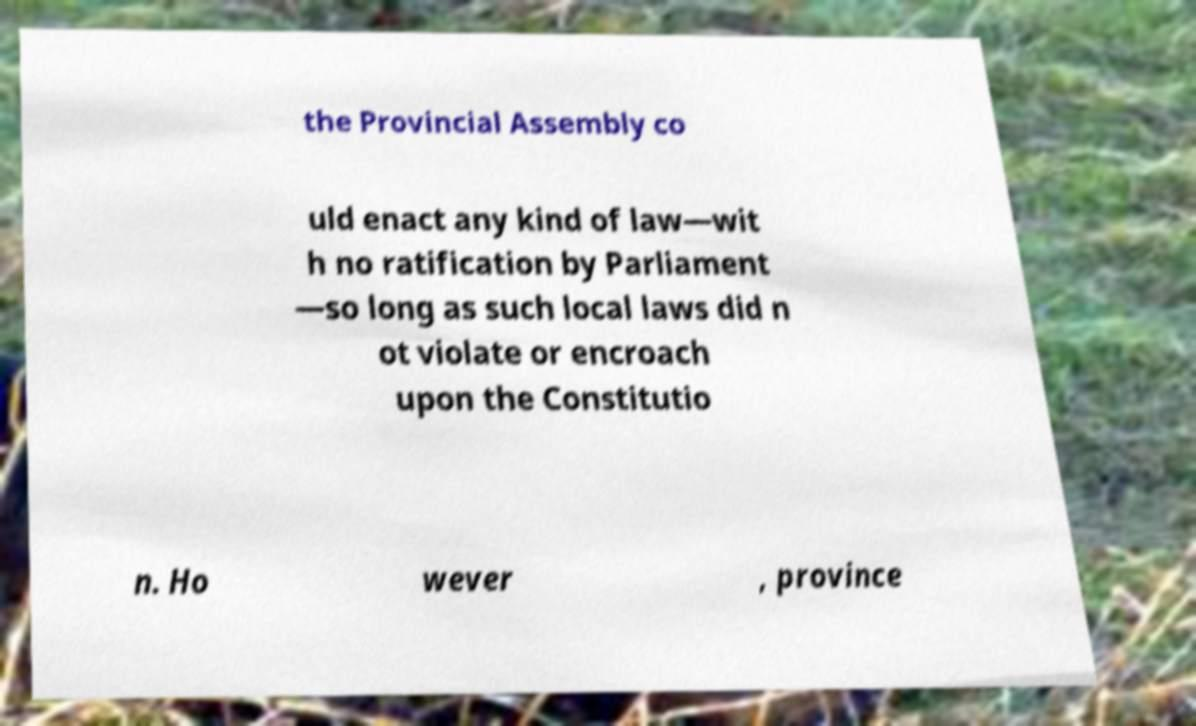Please read and relay the text visible in this image. What does it say? the Provincial Assembly co uld enact any kind of law—wit h no ratification by Parliament —so long as such local laws did n ot violate or encroach upon the Constitutio n. Ho wever , province 